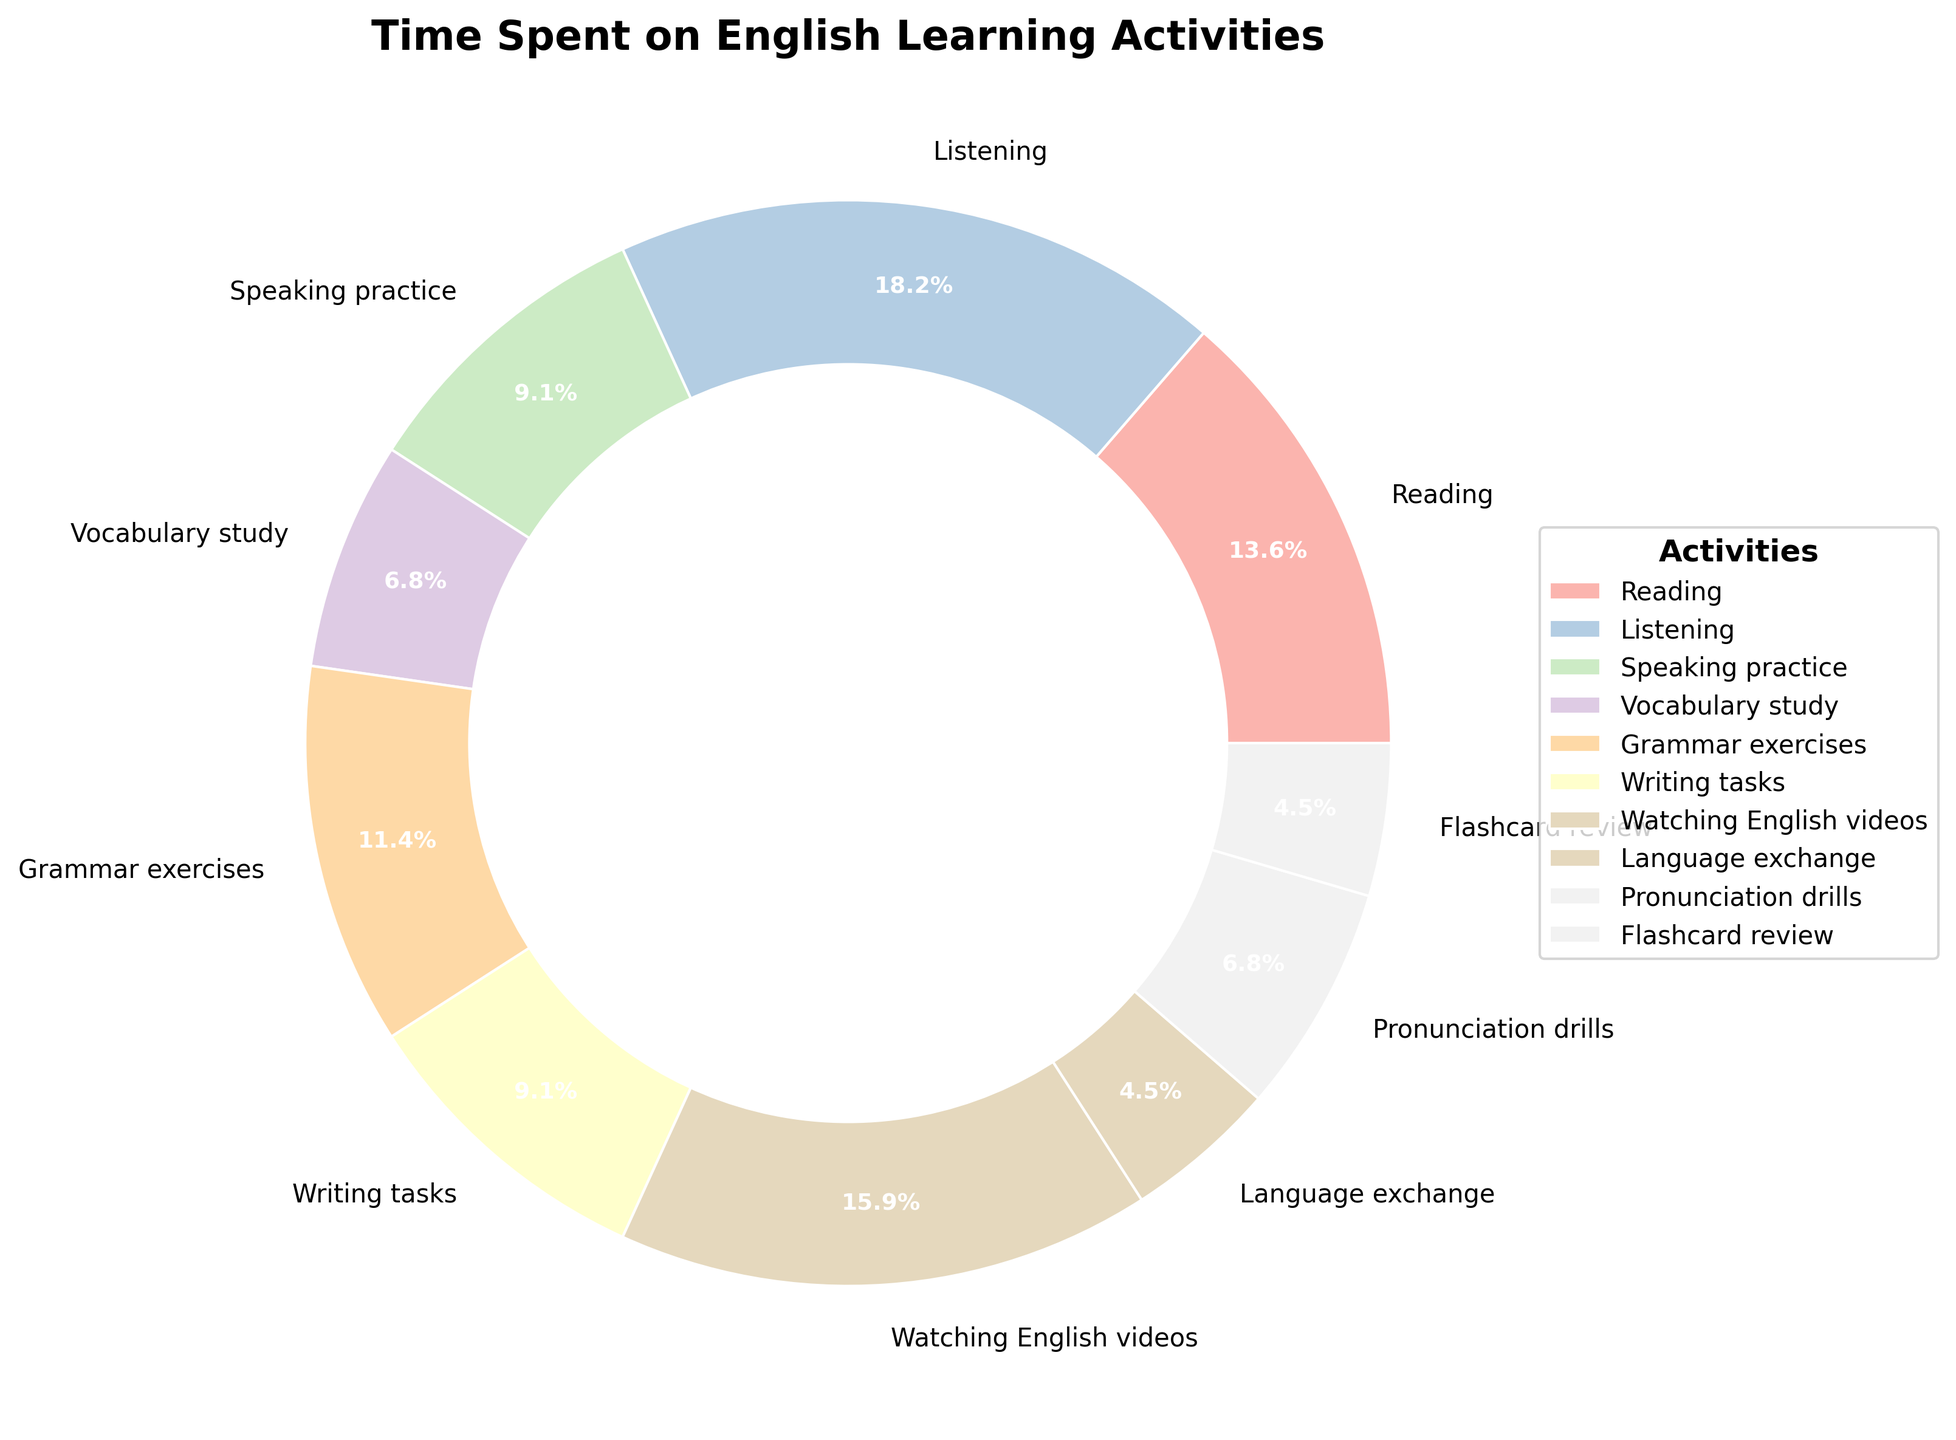What activity has the highest percentage of time spent? Look at the slices of the pie chart and find the largest slice. The largest slice represents the activity with the highest percentage of time.
Answer: Listening What is the combined percentage of time spent on Grammar exercises and Pronunciation drills? Find the slices for Grammar exercises and Pronunciation drills, and add their percentages together.
Answer: 16.7% Is more time spent on Speaking practice or Writing tasks? Compare the percentages of time spent on Speaking practice and Writing tasks.
Answer: They are equal What activity takes up less time: Language exchange or Flashcard review? Compare the percentages of time spent on Language exchange and Flashcard review.
Answer: They are equal Which activity has the smallest percentage of time spent? Find the smallest slice in the pie chart; this represents the activity with the smallest percentage of time.
Answer: Language exchange and Flashcard review What is the total time spent on Reading, Watching English videos, and Vocabulary study? Look at the slices for Reading, Watching English videos, and Vocabulary study and sum their percentages: (90/660) * 100 + (105/660) * 100 + (45/660) * 100.
Answer: 36.4% Are Pronunciation drills and Flashcard review together more than Grammar exercises? Add the percentages of Pronunciation drills and Flashcard review, then compare with the percentage of Grammar exercises.
Answer: No What is the difference in the percentage of time spent between Listening and Vocabulary study? Calculate the percentage for Listening: (120/660) * 100 = 18.2, and for Vocabulary study: (45/660) * 100 = 6.8. Subtract the smaller percentage from the larger one.
Answer: 11.4% What proportion of the total time is spent on Reading? Calculate the percentage for Reading: (90/660) * 100.
Answer: 13.6% Which chunk of the pie chart is pink in color? By looking at the pie chart, identify which activity is represented by the pink color.
Answer: Speaking practice 